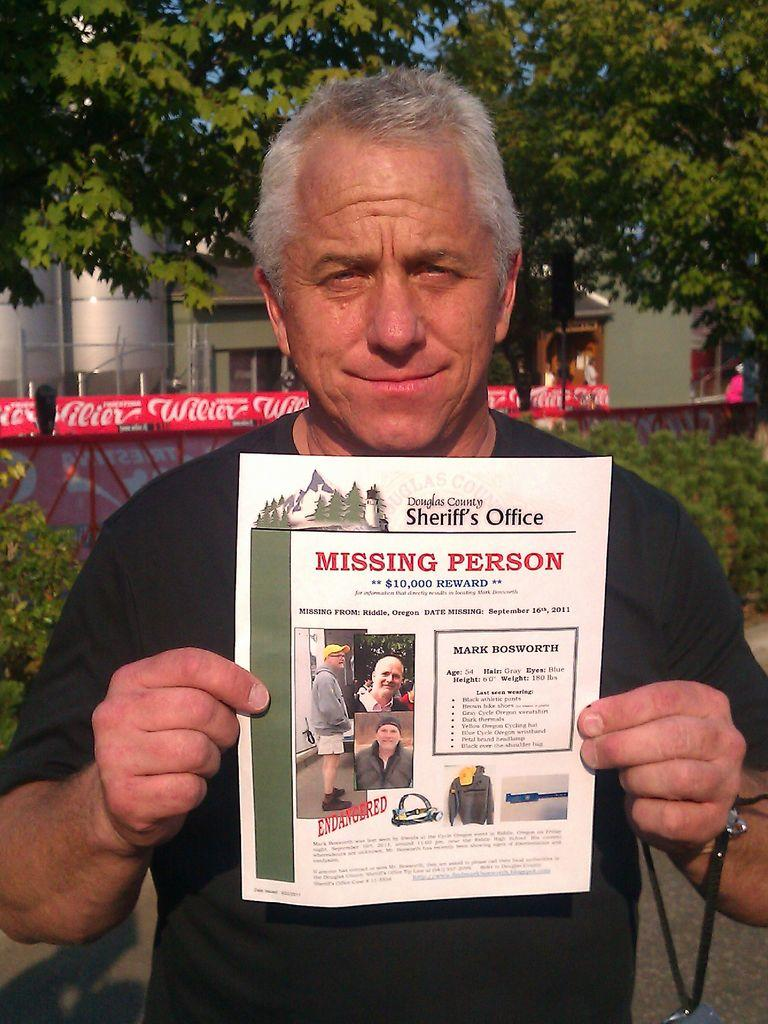Who is the main subject in the image? There is a man in the image. What is the man holding in the image? The man is holding a pamphlet. What can be found inside the pamphlet? The pamphlet contains text and pictures of a man. What can be seen in the background of the image? There are trees, houses, and plants in the background of the image. How many icicles are hanging from the man's hat in the image? There are no icicles present in the image. What type of relationship do the brothers in the image have with each other? There are no brothers present in the image. 